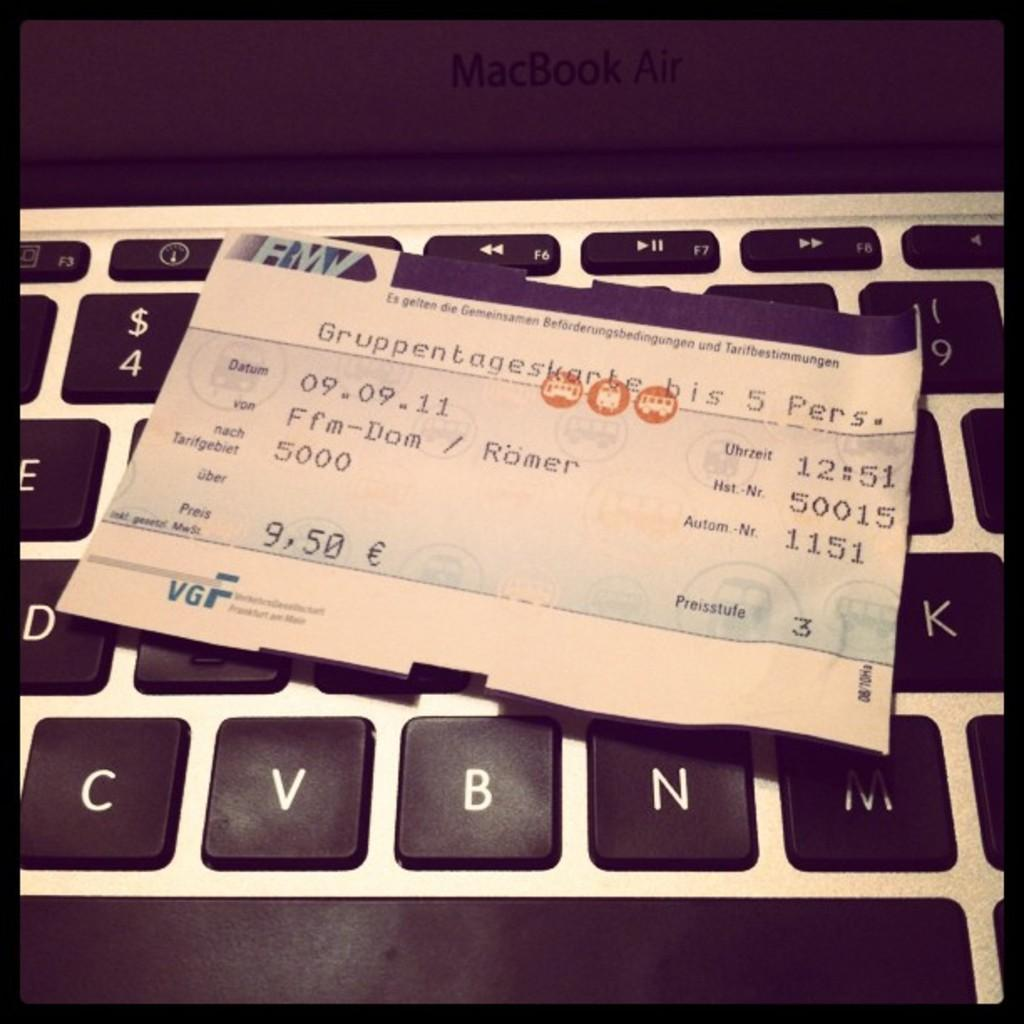<image>
Render a clear and concise summary of the photo. 9,50 is the total cost displayed on the receipt. 